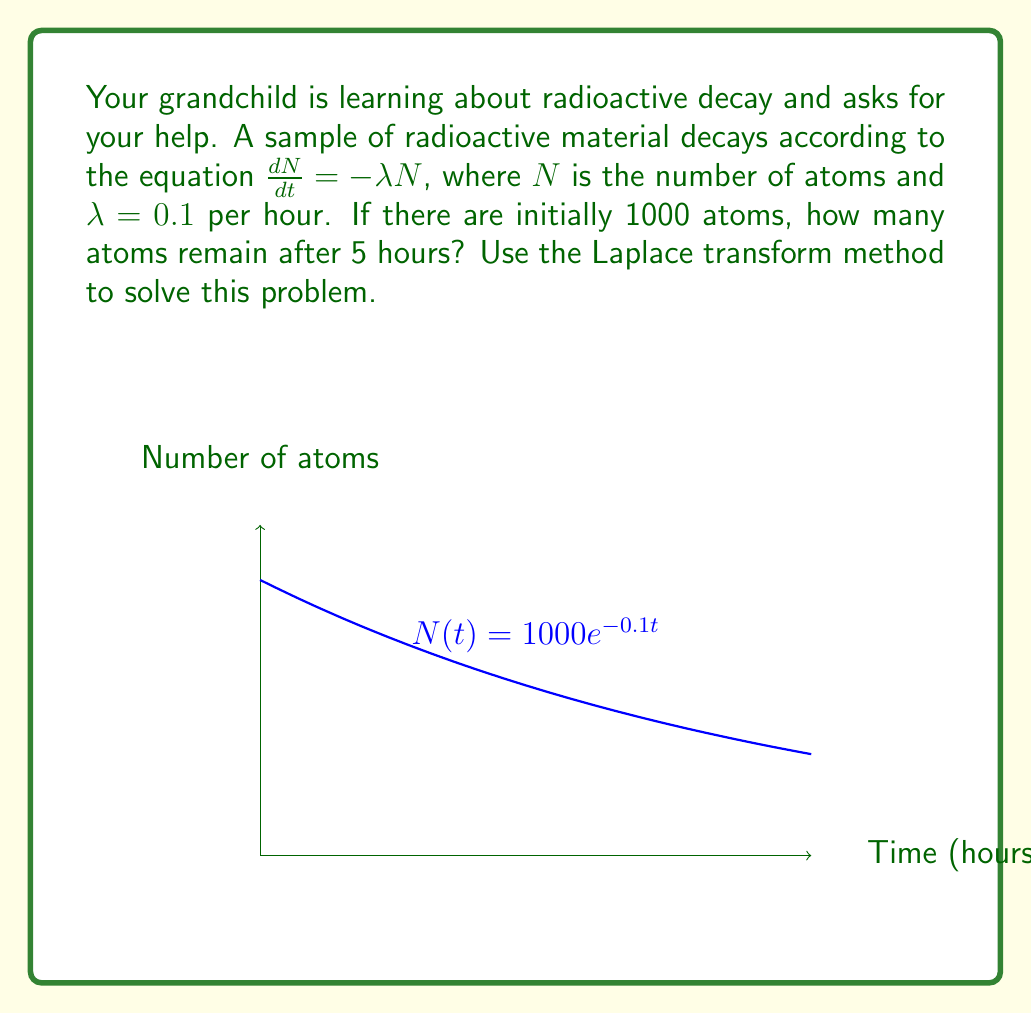Give your solution to this math problem. Let's solve this step-by-step using the Laplace transform:

1) The differential equation is $\frac{dN}{dt} = -\lambda N$ with $\lambda = 0.1$ and initial condition $N(0) = 1000$.

2) Take the Laplace transform of both sides:
   $$\mathcal{L}\left\{\frac{dN}{dt}\right\} = \mathcal{L}\{-0.1N\}$$

3) Using Laplace transform properties:
   $$s\mathcal{L}\{N\} - N(0) = -0.1\mathcal{L}\{N\}$$

4) Let $\mathcal{L}\{N\} = F(s)$. Substitute $N(0) = 1000$:
   $$sF(s) - 1000 = -0.1F(s)$$

5) Solve for $F(s)$:
   $$(s + 0.1)F(s) = 1000$$
   $$F(s) = \frac{1000}{s + 0.1}$$

6) Take the inverse Laplace transform:
   $$N(t) = \mathcal{L}^{-1}\left\{\frac{1000}{s + 0.1}\right\} = 1000e^{-0.1t}$$

7) To find $N(5)$, substitute $t = 5$:
   $$N(5) = 1000e^{-0.1(5)} = 1000e^{-0.5} \approx 606.53$$

Therefore, after 5 hours, approximately 607 atoms remain.
Answer: 607 atoms 